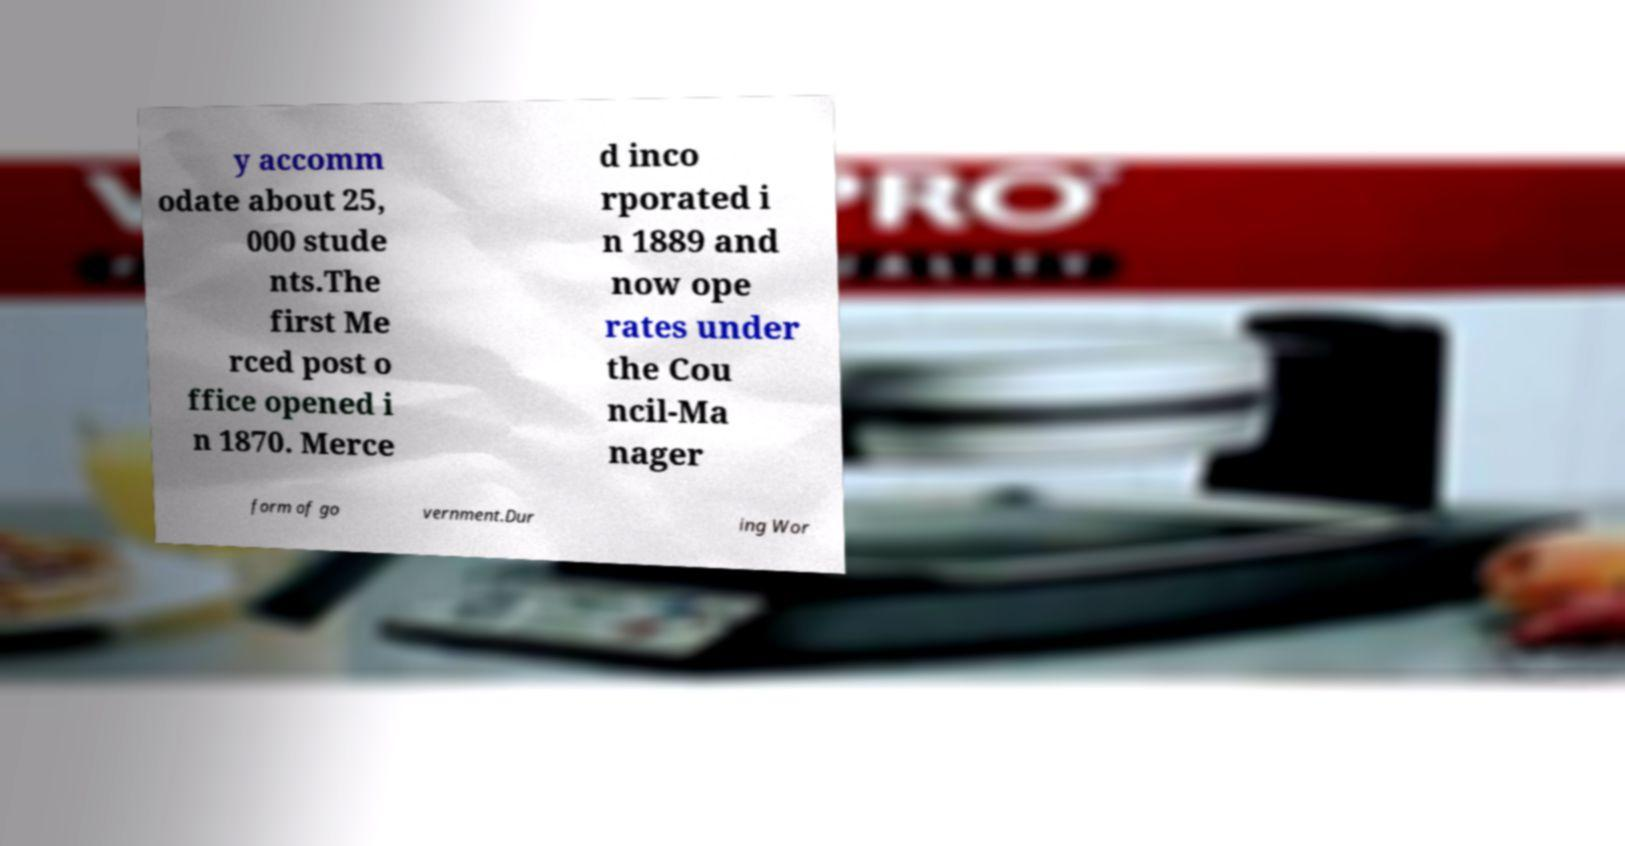Can you read and provide the text displayed in the image?This photo seems to have some interesting text. Can you extract and type it out for me? y accomm odate about 25, 000 stude nts.The first Me rced post o ffice opened i n 1870. Merce d inco rporated i n 1889 and now ope rates under the Cou ncil-Ma nager form of go vernment.Dur ing Wor 